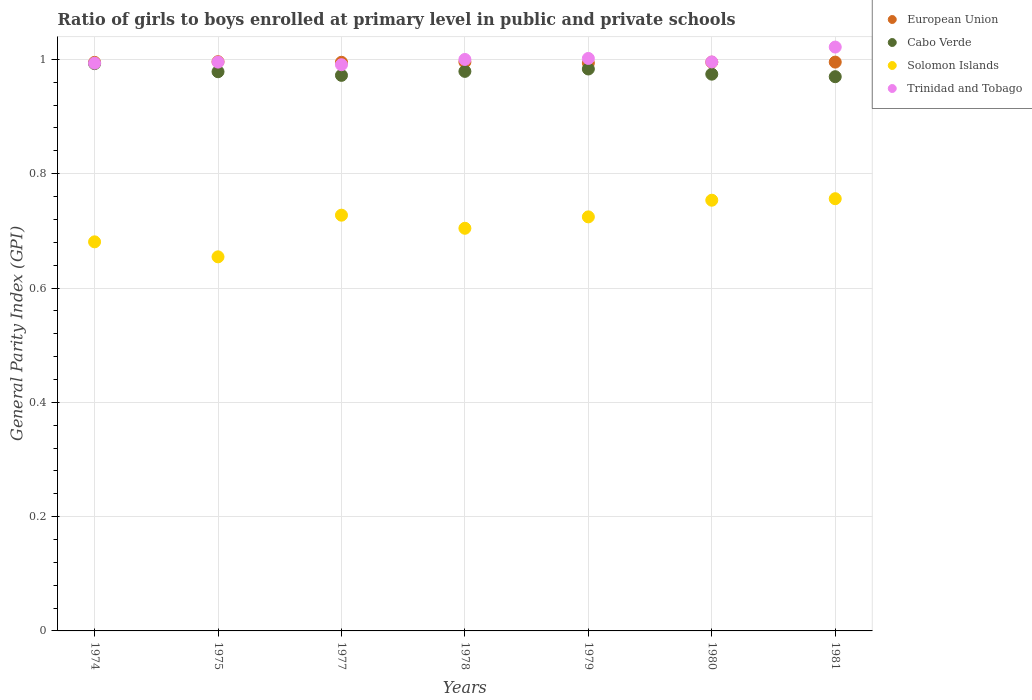What is the general parity index in Trinidad and Tobago in 1975?
Keep it short and to the point. 1. Across all years, what is the maximum general parity index in Cabo Verde?
Ensure brevity in your answer.  0.99. Across all years, what is the minimum general parity index in Trinidad and Tobago?
Your answer should be compact. 0.99. In which year was the general parity index in Solomon Islands maximum?
Provide a short and direct response. 1981. What is the total general parity index in Trinidad and Tobago in the graph?
Give a very brief answer. 7. What is the difference between the general parity index in Cabo Verde in 1978 and that in 1979?
Your response must be concise. -0. What is the difference between the general parity index in European Union in 1975 and the general parity index in Trinidad and Tobago in 1974?
Your response must be concise. 0. What is the average general parity index in Cabo Verde per year?
Offer a very short reply. 0.98. In the year 1978, what is the difference between the general parity index in Cabo Verde and general parity index in European Union?
Offer a terse response. -0.02. What is the ratio of the general parity index in European Union in 1974 to that in 1981?
Ensure brevity in your answer.  1. Is the general parity index in European Union in 1975 less than that in 1981?
Your answer should be compact. No. What is the difference between the highest and the second highest general parity index in Trinidad and Tobago?
Provide a succinct answer. 0.02. What is the difference between the highest and the lowest general parity index in Trinidad and Tobago?
Your answer should be compact. 0.03. In how many years, is the general parity index in Cabo Verde greater than the average general parity index in Cabo Verde taken over all years?
Ensure brevity in your answer.  3. Is the sum of the general parity index in Trinidad and Tobago in 1975 and 1981 greater than the maximum general parity index in Cabo Verde across all years?
Give a very brief answer. Yes. Is it the case that in every year, the sum of the general parity index in Trinidad and Tobago and general parity index in Cabo Verde  is greater than the sum of general parity index in Solomon Islands and general parity index in European Union?
Your answer should be compact. No. Is the general parity index in European Union strictly greater than the general parity index in Solomon Islands over the years?
Offer a terse response. Yes. How many years are there in the graph?
Ensure brevity in your answer.  7. Are the values on the major ticks of Y-axis written in scientific E-notation?
Ensure brevity in your answer.  No. Does the graph contain any zero values?
Offer a terse response. No. Does the graph contain grids?
Make the answer very short. Yes. Where does the legend appear in the graph?
Your response must be concise. Top right. How many legend labels are there?
Your response must be concise. 4. What is the title of the graph?
Offer a terse response. Ratio of girls to boys enrolled at primary level in public and private schools. What is the label or title of the X-axis?
Your response must be concise. Years. What is the label or title of the Y-axis?
Keep it short and to the point. General Parity Index (GPI). What is the General Parity Index (GPI) in European Union in 1974?
Your answer should be compact. 0.99. What is the General Parity Index (GPI) of Cabo Verde in 1974?
Provide a short and direct response. 0.99. What is the General Parity Index (GPI) in Solomon Islands in 1974?
Provide a short and direct response. 0.68. What is the General Parity Index (GPI) in Trinidad and Tobago in 1974?
Your answer should be compact. 0.99. What is the General Parity Index (GPI) of European Union in 1975?
Offer a terse response. 1. What is the General Parity Index (GPI) in Cabo Verde in 1975?
Offer a very short reply. 0.98. What is the General Parity Index (GPI) in Solomon Islands in 1975?
Your response must be concise. 0.65. What is the General Parity Index (GPI) in European Union in 1977?
Offer a very short reply. 0.99. What is the General Parity Index (GPI) of Cabo Verde in 1977?
Offer a terse response. 0.97. What is the General Parity Index (GPI) in Solomon Islands in 1977?
Provide a succinct answer. 0.73. What is the General Parity Index (GPI) of Trinidad and Tobago in 1977?
Ensure brevity in your answer.  0.99. What is the General Parity Index (GPI) in European Union in 1978?
Offer a terse response. 1. What is the General Parity Index (GPI) of Cabo Verde in 1978?
Your answer should be very brief. 0.98. What is the General Parity Index (GPI) in Solomon Islands in 1978?
Provide a short and direct response. 0.7. What is the General Parity Index (GPI) in Trinidad and Tobago in 1978?
Provide a succinct answer. 1. What is the General Parity Index (GPI) in European Union in 1979?
Keep it short and to the point. 0.99. What is the General Parity Index (GPI) in Cabo Verde in 1979?
Your answer should be very brief. 0.98. What is the General Parity Index (GPI) in Solomon Islands in 1979?
Your answer should be compact. 0.72. What is the General Parity Index (GPI) in Trinidad and Tobago in 1979?
Keep it short and to the point. 1. What is the General Parity Index (GPI) of European Union in 1980?
Provide a succinct answer. 1. What is the General Parity Index (GPI) of Cabo Verde in 1980?
Make the answer very short. 0.97. What is the General Parity Index (GPI) of Solomon Islands in 1980?
Your answer should be compact. 0.75. What is the General Parity Index (GPI) of Trinidad and Tobago in 1980?
Offer a terse response. 1. What is the General Parity Index (GPI) of European Union in 1981?
Provide a succinct answer. 1. What is the General Parity Index (GPI) in Cabo Verde in 1981?
Provide a short and direct response. 0.97. What is the General Parity Index (GPI) of Solomon Islands in 1981?
Give a very brief answer. 0.76. What is the General Parity Index (GPI) in Trinidad and Tobago in 1981?
Provide a succinct answer. 1.02. Across all years, what is the maximum General Parity Index (GPI) in European Union?
Offer a very short reply. 1. Across all years, what is the maximum General Parity Index (GPI) of Cabo Verde?
Provide a succinct answer. 0.99. Across all years, what is the maximum General Parity Index (GPI) in Solomon Islands?
Offer a terse response. 0.76. Across all years, what is the maximum General Parity Index (GPI) in Trinidad and Tobago?
Give a very brief answer. 1.02. Across all years, what is the minimum General Parity Index (GPI) in European Union?
Your answer should be compact. 0.99. Across all years, what is the minimum General Parity Index (GPI) of Cabo Verde?
Your response must be concise. 0.97. Across all years, what is the minimum General Parity Index (GPI) in Solomon Islands?
Provide a short and direct response. 0.65. Across all years, what is the minimum General Parity Index (GPI) in Trinidad and Tobago?
Offer a terse response. 0.99. What is the total General Parity Index (GPI) in European Union in the graph?
Offer a terse response. 6.97. What is the total General Parity Index (GPI) of Cabo Verde in the graph?
Your answer should be compact. 6.85. What is the total General Parity Index (GPI) in Solomon Islands in the graph?
Your answer should be very brief. 5. What is the total General Parity Index (GPI) in Trinidad and Tobago in the graph?
Give a very brief answer. 7. What is the difference between the General Parity Index (GPI) of European Union in 1974 and that in 1975?
Your answer should be compact. -0. What is the difference between the General Parity Index (GPI) in Cabo Verde in 1974 and that in 1975?
Provide a short and direct response. 0.01. What is the difference between the General Parity Index (GPI) in Solomon Islands in 1974 and that in 1975?
Ensure brevity in your answer.  0.03. What is the difference between the General Parity Index (GPI) of Trinidad and Tobago in 1974 and that in 1975?
Give a very brief answer. -0. What is the difference between the General Parity Index (GPI) of European Union in 1974 and that in 1977?
Provide a succinct answer. -0. What is the difference between the General Parity Index (GPI) in Cabo Verde in 1974 and that in 1977?
Offer a very short reply. 0.02. What is the difference between the General Parity Index (GPI) of Solomon Islands in 1974 and that in 1977?
Offer a terse response. -0.05. What is the difference between the General Parity Index (GPI) in Trinidad and Tobago in 1974 and that in 1977?
Give a very brief answer. 0. What is the difference between the General Parity Index (GPI) of European Union in 1974 and that in 1978?
Provide a short and direct response. -0. What is the difference between the General Parity Index (GPI) of Cabo Verde in 1974 and that in 1978?
Your answer should be very brief. 0.01. What is the difference between the General Parity Index (GPI) of Solomon Islands in 1974 and that in 1978?
Your answer should be compact. -0.02. What is the difference between the General Parity Index (GPI) of Trinidad and Tobago in 1974 and that in 1978?
Provide a short and direct response. -0.01. What is the difference between the General Parity Index (GPI) in European Union in 1974 and that in 1979?
Offer a very short reply. 0. What is the difference between the General Parity Index (GPI) in Cabo Verde in 1974 and that in 1979?
Provide a succinct answer. 0.01. What is the difference between the General Parity Index (GPI) in Solomon Islands in 1974 and that in 1979?
Offer a terse response. -0.04. What is the difference between the General Parity Index (GPI) in Trinidad and Tobago in 1974 and that in 1979?
Give a very brief answer. -0.01. What is the difference between the General Parity Index (GPI) of European Union in 1974 and that in 1980?
Offer a terse response. -0. What is the difference between the General Parity Index (GPI) of Cabo Verde in 1974 and that in 1980?
Offer a very short reply. 0.02. What is the difference between the General Parity Index (GPI) of Solomon Islands in 1974 and that in 1980?
Give a very brief answer. -0.07. What is the difference between the General Parity Index (GPI) of Trinidad and Tobago in 1974 and that in 1980?
Provide a short and direct response. -0. What is the difference between the General Parity Index (GPI) in European Union in 1974 and that in 1981?
Provide a succinct answer. -0. What is the difference between the General Parity Index (GPI) in Cabo Verde in 1974 and that in 1981?
Give a very brief answer. 0.02. What is the difference between the General Parity Index (GPI) of Solomon Islands in 1974 and that in 1981?
Provide a short and direct response. -0.08. What is the difference between the General Parity Index (GPI) of Trinidad and Tobago in 1974 and that in 1981?
Ensure brevity in your answer.  -0.03. What is the difference between the General Parity Index (GPI) of Cabo Verde in 1975 and that in 1977?
Give a very brief answer. 0.01. What is the difference between the General Parity Index (GPI) of Solomon Islands in 1975 and that in 1977?
Provide a short and direct response. -0.07. What is the difference between the General Parity Index (GPI) of Trinidad and Tobago in 1975 and that in 1977?
Make the answer very short. 0. What is the difference between the General Parity Index (GPI) in European Union in 1975 and that in 1978?
Ensure brevity in your answer.  0. What is the difference between the General Parity Index (GPI) in Cabo Verde in 1975 and that in 1978?
Ensure brevity in your answer.  -0. What is the difference between the General Parity Index (GPI) in Solomon Islands in 1975 and that in 1978?
Your answer should be compact. -0.05. What is the difference between the General Parity Index (GPI) of Trinidad and Tobago in 1975 and that in 1978?
Give a very brief answer. -0. What is the difference between the General Parity Index (GPI) in European Union in 1975 and that in 1979?
Your response must be concise. 0. What is the difference between the General Parity Index (GPI) of Cabo Verde in 1975 and that in 1979?
Provide a succinct answer. -0. What is the difference between the General Parity Index (GPI) in Solomon Islands in 1975 and that in 1979?
Provide a succinct answer. -0.07. What is the difference between the General Parity Index (GPI) of Trinidad and Tobago in 1975 and that in 1979?
Provide a short and direct response. -0.01. What is the difference between the General Parity Index (GPI) in European Union in 1975 and that in 1980?
Provide a succinct answer. 0. What is the difference between the General Parity Index (GPI) of Cabo Verde in 1975 and that in 1980?
Offer a very short reply. 0. What is the difference between the General Parity Index (GPI) in Solomon Islands in 1975 and that in 1980?
Your response must be concise. -0.1. What is the difference between the General Parity Index (GPI) of Trinidad and Tobago in 1975 and that in 1980?
Your answer should be compact. -0. What is the difference between the General Parity Index (GPI) in European Union in 1975 and that in 1981?
Make the answer very short. 0. What is the difference between the General Parity Index (GPI) in Cabo Verde in 1975 and that in 1981?
Offer a very short reply. 0.01. What is the difference between the General Parity Index (GPI) of Solomon Islands in 1975 and that in 1981?
Your answer should be very brief. -0.1. What is the difference between the General Parity Index (GPI) of Trinidad and Tobago in 1975 and that in 1981?
Your answer should be compact. -0.03. What is the difference between the General Parity Index (GPI) of European Union in 1977 and that in 1978?
Your response must be concise. -0. What is the difference between the General Parity Index (GPI) in Cabo Verde in 1977 and that in 1978?
Your response must be concise. -0.01. What is the difference between the General Parity Index (GPI) in Solomon Islands in 1977 and that in 1978?
Your response must be concise. 0.02. What is the difference between the General Parity Index (GPI) in Trinidad and Tobago in 1977 and that in 1978?
Make the answer very short. -0.01. What is the difference between the General Parity Index (GPI) in European Union in 1977 and that in 1979?
Make the answer very short. 0. What is the difference between the General Parity Index (GPI) of Cabo Verde in 1977 and that in 1979?
Offer a very short reply. -0.01. What is the difference between the General Parity Index (GPI) of Solomon Islands in 1977 and that in 1979?
Offer a very short reply. 0. What is the difference between the General Parity Index (GPI) in Trinidad and Tobago in 1977 and that in 1979?
Ensure brevity in your answer.  -0.01. What is the difference between the General Parity Index (GPI) of European Union in 1977 and that in 1980?
Give a very brief answer. -0. What is the difference between the General Parity Index (GPI) of Cabo Verde in 1977 and that in 1980?
Provide a succinct answer. -0. What is the difference between the General Parity Index (GPI) in Solomon Islands in 1977 and that in 1980?
Your response must be concise. -0.03. What is the difference between the General Parity Index (GPI) in Trinidad and Tobago in 1977 and that in 1980?
Provide a succinct answer. -0. What is the difference between the General Parity Index (GPI) of European Union in 1977 and that in 1981?
Your answer should be very brief. -0. What is the difference between the General Parity Index (GPI) of Cabo Verde in 1977 and that in 1981?
Provide a short and direct response. 0. What is the difference between the General Parity Index (GPI) in Solomon Islands in 1977 and that in 1981?
Make the answer very short. -0.03. What is the difference between the General Parity Index (GPI) of Trinidad and Tobago in 1977 and that in 1981?
Provide a short and direct response. -0.03. What is the difference between the General Parity Index (GPI) of European Union in 1978 and that in 1979?
Your answer should be very brief. 0. What is the difference between the General Parity Index (GPI) in Cabo Verde in 1978 and that in 1979?
Provide a succinct answer. -0. What is the difference between the General Parity Index (GPI) of Solomon Islands in 1978 and that in 1979?
Offer a terse response. -0.02. What is the difference between the General Parity Index (GPI) of Trinidad and Tobago in 1978 and that in 1979?
Ensure brevity in your answer.  -0. What is the difference between the General Parity Index (GPI) in Cabo Verde in 1978 and that in 1980?
Your answer should be very brief. 0. What is the difference between the General Parity Index (GPI) in Solomon Islands in 1978 and that in 1980?
Provide a short and direct response. -0.05. What is the difference between the General Parity Index (GPI) in Trinidad and Tobago in 1978 and that in 1980?
Your answer should be very brief. 0. What is the difference between the General Parity Index (GPI) of European Union in 1978 and that in 1981?
Offer a terse response. 0. What is the difference between the General Parity Index (GPI) in Cabo Verde in 1978 and that in 1981?
Provide a succinct answer. 0.01. What is the difference between the General Parity Index (GPI) of Solomon Islands in 1978 and that in 1981?
Keep it short and to the point. -0.05. What is the difference between the General Parity Index (GPI) in Trinidad and Tobago in 1978 and that in 1981?
Offer a very short reply. -0.02. What is the difference between the General Parity Index (GPI) of European Union in 1979 and that in 1980?
Make the answer very short. -0. What is the difference between the General Parity Index (GPI) in Cabo Verde in 1979 and that in 1980?
Your response must be concise. 0.01. What is the difference between the General Parity Index (GPI) in Solomon Islands in 1979 and that in 1980?
Your answer should be very brief. -0.03. What is the difference between the General Parity Index (GPI) in Trinidad and Tobago in 1979 and that in 1980?
Your answer should be very brief. 0.01. What is the difference between the General Parity Index (GPI) in European Union in 1979 and that in 1981?
Make the answer very short. -0. What is the difference between the General Parity Index (GPI) in Cabo Verde in 1979 and that in 1981?
Your response must be concise. 0.01. What is the difference between the General Parity Index (GPI) in Solomon Islands in 1979 and that in 1981?
Provide a short and direct response. -0.03. What is the difference between the General Parity Index (GPI) of Trinidad and Tobago in 1979 and that in 1981?
Your answer should be very brief. -0.02. What is the difference between the General Parity Index (GPI) in European Union in 1980 and that in 1981?
Provide a succinct answer. -0. What is the difference between the General Parity Index (GPI) in Cabo Verde in 1980 and that in 1981?
Your answer should be very brief. 0. What is the difference between the General Parity Index (GPI) in Solomon Islands in 1980 and that in 1981?
Make the answer very short. -0. What is the difference between the General Parity Index (GPI) in Trinidad and Tobago in 1980 and that in 1981?
Keep it short and to the point. -0.03. What is the difference between the General Parity Index (GPI) of European Union in 1974 and the General Parity Index (GPI) of Cabo Verde in 1975?
Provide a succinct answer. 0.02. What is the difference between the General Parity Index (GPI) of European Union in 1974 and the General Parity Index (GPI) of Solomon Islands in 1975?
Keep it short and to the point. 0.34. What is the difference between the General Parity Index (GPI) of European Union in 1974 and the General Parity Index (GPI) of Trinidad and Tobago in 1975?
Your answer should be compact. -0. What is the difference between the General Parity Index (GPI) in Cabo Verde in 1974 and the General Parity Index (GPI) in Solomon Islands in 1975?
Your answer should be very brief. 0.34. What is the difference between the General Parity Index (GPI) in Cabo Verde in 1974 and the General Parity Index (GPI) in Trinidad and Tobago in 1975?
Provide a succinct answer. -0. What is the difference between the General Parity Index (GPI) in Solomon Islands in 1974 and the General Parity Index (GPI) in Trinidad and Tobago in 1975?
Provide a succinct answer. -0.31. What is the difference between the General Parity Index (GPI) of European Union in 1974 and the General Parity Index (GPI) of Cabo Verde in 1977?
Your answer should be very brief. 0.02. What is the difference between the General Parity Index (GPI) of European Union in 1974 and the General Parity Index (GPI) of Solomon Islands in 1977?
Ensure brevity in your answer.  0.27. What is the difference between the General Parity Index (GPI) of European Union in 1974 and the General Parity Index (GPI) of Trinidad and Tobago in 1977?
Your answer should be very brief. 0. What is the difference between the General Parity Index (GPI) in Cabo Verde in 1974 and the General Parity Index (GPI) in Solomon Islands in 1977?
Offer a terse response. 0.27. What is the difference between the General Parity Index (GPI) in Cabo Verde in 1974 and the General Parity Index (GPI) in Trinidad and Tobago in 1977?
Ensure brevity in your answer.  0. What is the difference between the General Parity Index (GPI) of Solomon Islands in 1974 and the General Parity Index (GPI) of Trinidad and Tobago in 1977?
Make the answer very short. -0.31. What is the difference between the General Parity Index (GPI) in European Union in 1974 and the General Parity Index (GPI) in Cabo Verde in 1978?
Provide a short and direct response. 0.02. What is the difference between the General Parity Index (GPI) in European Union in 1974 and the General Parity Index (GPI) in Solomon Islands in 1978?
Your answer should be compact. 0.29. What is the difference between the General Parity Index (GPI) of European Union in 1974 and the General Parity Index (GPI) of Trinidad and Tobago in 1978?
Offer a terse response. -0.01. What is the difference between the General Parity Index (GPI) of Cabo Verde in 1974 and the General Parity Index (GPI) of Solomon Islands in 1978?
Your response must be concise. 0.29. What is the difference between the General Parity Index (GPI) in Cabo Verde in 1974 and the General Parity Index (GPI) in Trinidad and Tobago in 1978?
Provide a succinct answer. -0.01. What is the difference between the General Parity Index (GPI) in Solomon Islands in 1974 and the General Parity Index (GPI) in Trinidad and Tobago in 1978?
Your answer should be very brief. -0.32. What is the difference between the General Parity Index (GPI) of European Union in 1974 and the General Parity Index (GPI) of Cabo Verde in 1979?
Keep it short and to the point. 0.01. What is the difference between the General Parity Index (GPI) in European Union in 1974 and the General Parity Index (GPI) in Solomon Islands in 1979?
Your answer should be very brief. 0.27. What is the difference between the General Parity Index (GPI) of European Union in 1974 and the General Parity Index (GPI) of Trinidad and Tobago in 1979?
Provide a short and direct response. -0.01. What is the difference between the General Parity Index (GPI) in Cabo Verde in 1974 and the General Parity Index (GPI) in Solomon Islands in 1979?
Your answer should be compact. 0.27. What is the difference between the General Parity Index (GPI) of Cabo Verde in 1974 and the General Parity Index (GPI) of Trinidad and Tobago in 1979?
Keep it short and to the point. -0.01. What is the difference between the General Parity Index (GPI) in Solomon Islands in 1974 and the General Parity Index (GPI) in Trinidad and Tobago in 1979?
Offer a terse response. -0.32. What is the difference between the General Parity Index (GPI) of European Union in 1974 and the General Parity Index (GPI) of Cabo Verde in 1980?
Provide a succinct answer. 0.02. What is the difference between the General Parity Index (GPI) of European Union in 1974 and the General Parity Index (GPI) of Solomon Islands in 1980?
Your answer should be very brief. 0.24. What is the difference between the General Parity Index (GPI) of European Union in 1974 and the General Parity Index (GPI) of Trinidad and Tobago in 1980?
Ensure brevity in your answer.  -0. What is the difference between the General Parity Index (GPI) in Cabo Verde in 1974 and the General Parity Index (GPI) in Solomon Islands in 1980?
Provide a succinct answer. 0.24. What is the difference between the General Parity Index (GPI) in Cabo Verde in 1974 and the General Parity Index (GPI) in Trinidad and Tobago in 1980?
Your answer should be very brief. -0. What is the difference between the General Parity Index (GPI) of Solomon Islands in 1974 and the General Parity Index (GPI) of Trinidad and Tobago in 1980?
Ensure brevity in your answer.  -0.31. What is the difference between the General Parity Index (GPI) of European Union in 1974 and the General Parity Index (GPI) of Cabo Verde in 1981?
Make the answer very short. 0.03. What is the difference between the General Parity Index (GPI) in European Union in 1974 and the General Parity Index (GPI) in Solomon Islands in 1981?
Keep it short and to the point. 0.24. What is the difference between the General Parity Index (GPI) of European Union in 1974 and the General Parity Index (GPI) of Trinidad and Tobago in 1981?
Provide a short and direct response. -0.03. What is the difference between the General Parity Index (GPI) in Cabo Verde in 1974 and the General Parity Index (GPI) in Solomon Islands in 1981?
Offer a terse response. 0.24. What is the difference between the General Parity Index (GPI) of Cabo Verde in 1974 and the General Parity Index (GPI) of Trinidad and Tobago in 1981?
Provide a short and direct response. -0.03. What is the difference between the General Parity Index (GPI) in Solomon Islands in 1974 and the General Parity Index (GPI) in Trinidad and Tobago in 1981?
Make the answer very short. -0.34. What is the difference between the General Parity Index (GPI) in European Union in 1975 and the General Parity Index (GPI) in Cabo Verde in 1977?
Make the answer very short. 0.02. What is the difference between the General Parity Index (GPI) in European Union in 1975 and the General Parity Index (GPI) in Solomon Islands in 1977?
Your response must be concise. 0.27. What is the difference between the General Parity Index (GPI) of European Union in 1975 and the General Parity Index (GPI) of Trinidad and Tobago in 1977?
Ensure brevity in your answer.  0.01. What is the difference between the General Parity Index (GPI) in Cabo Verde in 1975 and the General Parity Index (GPI) in Solomon Islands in 1977?
Offer a very short reply. 0.25. What is the difference between the General Parity Index (GPI) in Cabo Verde in 1975 and the General Parity Index (GPI) in Trinidad and Tobago in 1977?
Your answer should be very brief. -0.01. What is the difference between the General Parity Index (GPI) in Solomon Islands in 1975 and the General Parity Index (GPI) in Trinidad and Tobago in 1977?
Your answer should be very brief. -0.34. What is the difference between the General Parity Index (GPI) in European Union in 1975 and the General Parity Index (GPI) in Cabo Verde in 1978?
Your response must be concise. 0.02. What is the difference between the General Parity Index (GPI) of European Union in 1975 and the General Parity Index (GPI) of Solomon Islands in 1978?
Your response must be concise. 0.29. What is the difference between the General Parity Index (GPI) in European Union in 1975 and the General Parity Index (GPI) in Trinidad and Tobago in 1978?
Your response must be concise. -0. What is the difference between the General Parity Index (GPI) in Cabo Verde in 1975 and the General Parity Index (GPI) in Solomon Islands in 1978?
Ensure brevity in your answer.  0.27. What is the difference between the General Parity Index (GPI) in Cabo Verde in 1975 and the General Parity Index (GPI) in Trinidad and Tobago in 1978?
Your response must be concise. -0.02. What is the difference between the General Parity Index (GPI) in Solomon Islands in 1975 and the General Parity Index (GPI) in Trinidad and Tobago in 1978?
Provide a short and direct response. -0.35. What is the difference between the General Parity Index (GPI) of European Union in 1975 and the General Parity Index (GPI) of Cabo Verde in 1979?
Make the answer very short. 0.01. What is the difference between the General Parity Index (GPI) of European Union in 1975 and the General Parity Index (GPI) of Solomon Islands in 1979?
Ensure brevity in your answer.  0.27. What is the difference between the General Parity Index (GPI) in European Union in 1975 and the General Parity Index (GPI) in Trinidad and Tobago in 1979?
Ensure brevity in your answer.  -0.01. What is the difference between the General Parity Index (GPI) in Cabo Verde in 1975 and the General Parity Index (GPI) in Solomon Islands in 1979?
Offer a terse response. 0.25. What is the difference between the General Parity Index (GPI) in Cabo Verde in 1975 and the General Parity Index (GPI) in Trinidad and Tobago in 1979?
Ensure brevity in your answer.  -0.02. What is the difference between the General Parity Index (GPI) of Solomon Islands in 1975 and the General Parity Index (GPI) of Trinidad and Tobago in 1979?
Offer a very short reply. -0.35. What is the difference between the General Parity Index (GPI) of European Union in 1975 and the General Parity Index (GPI) of Cabo Verde in 1980?
Offer a very short reply. 0.02. What is the difference between the General Parity Index (GPI) of European Union in 1975 and the General Parity Index (GPI) of Solomon Islands in 1980?
Ensure brevity in your answer.  0.24. What is the difference between the General Parity Index (GPI) in European Union in 1975 and the General Parity Index (GPI) in Trinidad and Tobago in 1980?
Ensure brevity in your answer.  0. What is the difference between the General Parity Index (GPI) in Cabo Verde in 1975 and the General Parity Index (GPI) in Solomon Islands in 1980?
Your response must be concise. 0.22. What is the difference between the General Parity Index (GPI) in Cabo Verde in 1975 and the General Parity Index (GPI) in Trinidad and Tobago in 1980?
Offer a terse response. -0.02. What is the difference between the General Parity Index (GPI) of Solomon Islands in 1975 and the General Parity Index (GPI) of Trinidad and Tobago in 1980?
Offer a terse response. -0.34. What is the difference between the General Parity Index (GPI) of European Union in 1975 and the General Parity Index (GPI) of Cabo Verde in 1981?
Make the answer very short. 0.03. What is the difference between the General Parity Index (GPI) of European Union in 1975 and the General Parity Index (GPI) of Solomon Islands in 1981?
Offer a very short reply. 0.24. What is the difference between the General Parity Index (GPI) in European Union in 1975 and the General Parity Index (GPI) in Trinidad and Tobago in 1981?
Make the answer very short. -0.03. What is the difference between the General Parity Index (GPI) in Cabo Verde in 1975 and the General Parity Index (GPI) in Solomon Islands in 1981?
Your answer should be very brief. 0.22. What is the difference between the General Parity Index (GPI) of Cabo Verde in 1975 and the General Parity Index (GPI) of Trinidad and Tobago in 1981?
Ensure brevity in your answer.  -0.04. What is the difference between the General Parity Index (GPI) of Solomon Islands in 1975 and the General Parity Index (GPI) of Trinidad and Tobago in 1981?
Make the answer very short. -0.37. What is the difference between the General Parity Index (GPI) in European Union in 1977 and the General Parity Index (GPI) in Cabo Verde in 1978?
Your answer should be very brief. 0.02. What is the difference between the General Parity Index (GPI) of European Union in 1977 and the General Parity Index (GPI) of Solomon Islands in 1978?
Make the answer very short. 0.29. What is the difference between the General Parity Index (GPI) of European Union in 1977 and the General Parity Index (GPI) of Trinidad and Tobago in 1978?
Offer a very short reply. -0. What is the difference between the General Parity Index (GPI) of Cabo Verde in 1977 and the General Parity Index (GPI) of Solomon Islands in 1978?
Offer a very short reply. 0.27. What is the difference between the General Parity Index (GPI) in Cabo Verde in 1977 and the General Parity Index (GPI) in Trinidad and Tobago in 1978?
Make the answer very short. -0.03. What is the difference between the General Parity Index (GPI) in Solomon Islands in 1977 and the General Parity Index (GPI) in Trinidad and Tobago in 1978?
Give a very brief answer. -0.27. What is the difference between the General Parity Index (GPI) in European Union in 1977 and the General Parity Index (GPI) in Cabo Verde in 1979?
Provide a short and direct response. 0.01. What is the difference between the General Parity Index (GPI) in European Union in 1977 and the General Parity Index (GPI) in Solomon Islands in 1979?
Provide a short and direct response. 0.27. What is the difference between the General Parity Index (GPI) in European Union in 1977 and the General Parity Index (GPI) in Trinidad and Tobago in 1979?
Your response must be concise. -0.01. What is the difference between the General Parity Index (GPI) in Cabo Verde in 1977 and the General Parity Index (GPI) in Solomon Islands in 1979?
Give a very brief answer. 0.25. What is the difference between the General Parity Index (GPI) in Cabo Verde in 1977 and the General Parity Index (GPI) in Trinidad and Tobago in 1979?
Give a very brief answer. -0.03. What is the difference between the General Parity Index (GPI) in Solomon Islands in 1977 and the General Parity Index (GPI) in Trinidad and Tobago in 1979?
Ensure brevity in your answer.  -0.27. What is the difference between the General Parity Index (GPI) of European Union in 1977 and the General Parity Index (GPI) of Cabo Verde in 1980?
Your answer should be compact. 0.02. What is the difference between the General Parity Index (GPI) of European Union in 1977 and the General Parity Index (GPI) of Solomon Islands in 1980?
Your response must be concise. 0.24. What is the difference between the General Parity Index (GPI) of European Union in 1977 and the General Parity Index (GPI) of Trinidad and Tobago in 1980?
Offer a terse response. -0. What is the difference between the General Parity Index (GPI) in Cabo Verde in 1977 and the General Parity Index (GPI) in Solomon Islands in 1980?
Give a very brief answer. 0.22. What is the difference between the General Parity Index (GPI) in Cabo Verde in 1977 and the General Parity Index (GPI) in Trinidad and Tobago in 1980?
Make the answer very short. -0.02. What is the difference between the General Parity Index (GPI) in Solomon Islands in 1977 and the General Parity Index (GPI) in Trinidad and Tobago in 1980?
Your answer should be very brief. -0.27. What is the difference between the General Parity Index (GPI) in European Union in 1977 and the General Parity Index (GPI) in Cabo Verde in 1981?
Your answer should be very brief. 0.03. What is the difference between the General Parity Index (GPI) in European Union in 1977 and the General Parity Index (GPI) in Solomon Islands in 1981?
Make the answer very short. 0.24. What is the difference between the General Parity Index (GPI) in European Union in 1977 and the General Parity Index (GPI) in Trinidad and Tobago in 1981?
Your response must be concise. -0.03. What is the difference between the General Parity Index (GPI) of Cabo Verde in 1977 and the General Parity Index (GPI) of Solomon Islands in 1981?
Provide a short and direct response. 0.22. What is the difference between the General Parity Index (GPI) of Cabo Verde in 1977 and the General Parity Index (GPI) of Trinidad and Tobago in 1981?
Offer a terse response. -0.05. What is the difference between the General Parity Index (GPI) in Solomon Islands in 1977 and the General Parity Index (GPI) in Trinidad and Tobago in 1981?
Your answer should be compact. -0.29. What is the difference between the General Parity Index (GPI) of European Union in 1978 and the General Parity Index (GPI) of Cabo Verde in 1979?
Offer a very short reply. 0.01. What is the difference between the General Parity Index (GPI) of European Union in 1978 and the General Parity Index (GPI) of Solomon Islands in 1979?
Provide a succinct answer. 0.27. What is the difference between the General Parity Index (GPI) in European Union in 1978 and the General Parity Index (GPI) in Trinidad and Tobago in 1979?
Keep it short and to the point. -0.01. What is the difference between the General Parity Index (GPI) of Cabo Verde in 1978 and the General Parity Index (GPI) of Solomon Islands in 1979?
Provide a succinct answer. 0.25. What is the difference between the General Parity Index (GPI) of Cabo Verde in 1978 and the General Parity Index (GPI) of Trinidad and Tobago in 1979?
Give a very brief answer. -0.02. What is the difference between the General Parity Index (GPI) in Solomon Islands in 1978 and the General Parity Index (GPI) in Trinidad and Tobago in 1979?
Offer a very short reply. -0.3. What is the difference between the General Parity Index (GPI) of European Union in 1978 and the General Parity Index (GPI) of Cabo Verde in 1980?
Provide a short and direct response. 0.02. What is the difference between the General Parity Index (GPI) in European Union in 1978 and the General Parity Index (GPI) in Solomon Islands in 1980?
Keep it short and to the point. 0.24. What is the difference between the General Parity Index (GPI) in European Union in 1978 and the General Parity Index (GPI) in Trinidad and Tobago in 1980?
Make the answer very short. -0. What is the difference between the General Parity Index (GPI) of Cabo Verde in 1978 and the General Parity Index (GPI) of Solomon Islands in 1980?
Ensure brevity in your answer.  0.23. What is the difference between the General Parity Index (GPI) in Cabo Verde in 1978 and the General Parity Index (GPI) in Trinidad and Tobago in 1980?
Ensure brevity in your answer.  -0.02. What is the difference between the General Parity Index (GPI) of Solomon Islands in 1978 and the General Parity Index (GPI) of Trinidad and Tobago in 1980?
Your answer should be very brief. -0.29. What is the difference between the General Parity Index (GPI) of European Union in 1978 and the General Parity Index (GPI) of Cabo Verde in 1981?
Offer a very short reply. 0.03. What is the difference between the General Parity Index (GPI) of European Union in 1978 and the General Parity Index (GPI) of Solomon Islands in 1981?
Make the answer very short. 0.24. What is the difference between the General Parity Index (GPI) in European Union in 1978 and the General Parity Index (GPI) in Trinidad and Tobago in 1981?
Keep it short and to the point. -0.03. What is the difference between the General Parity Index (GPI) in Cabo Verde in 1978 and the General Parity Index (GPI) in Solomon Islands in 1981?
Your response must be concise. 0.22. What is the difference between the General Parity Index (GPI) of Cabo Verde in 1978 and the General Parity Index (GPI) of Trinidad and Tobago in 1981?
Your response must be concise. -0.04. What is the difference between the General Parity Index (GPI) of Solomon Islands in 1978 and the General Parity Index (GPI) of Trinidad and Tobago in 1981?
Your answer should be very brief. -0.32. What is the difference between the General Parity Index (GPI) of European Union in 1979 and the General Parity Index (GPI) of Cabo Verde in 1980?
Your answer should be very brief. 0.02. What is the difference between the General Parity Index (GPI) in European Union in 1979 and the General Parity Index (GPI) in Solomon Islands in 1980?
Your response must be concise. 0.24. What is the difference between the General Parity Index (GPI) in European Union in 1979 and the General Parity Index (GPI) in Trinidad and Tobago in 1980?
Offer a terse response. -0. What is the difference between the General Parity Index (GPI) of Cabo Verde in 1979 and the General Parity Index (GPI) of Solomon Islands in 1980?
Offer a terse response. 0.23. What is the difference between the General Parity Index (GPI) of Cabo Verde in 1979 and the General Parity Index (GPI) of Trinidad and Tobago in 1980?
Offer a very short reply. -0.01. What is the difference between the General Parity Index (GPI) in Solomon Islands in 1979 and the General Parity Index (GPI) in Trinidad and Tobago in 1980?
Give a very brief answer. -0.27. What is the difference between the General Parity Index (GPI) of European Union in 1979 and the General Parity Index (GPI) of Cabo Verde in 1981?
Your answer should be compact. 0.02. What is the difference between the General Parity Index (GPI) in European Union in 1979 and the General Parity Index (GPI) in Solomon Islands in 1981?
Offer a terse response. 0.24. What is the difference between the General Parity Index (GPI) in European Union in 1979 and the General Parity Index (GPI) in Trinidad and Tobago in 1981?
Your answer should be very brief. -0.03. What is the difference between the General Parity Index (GPI) in Cabo Verde in 1979 and the General Parity Index (GPI) in Solomon Islands in 1981?
Provide a short and direct response. 0.23. What is the difference between the General Parity Index (GPI) in Cabo Verde in 1979 and the General Parity Index (GPI) in Trinidad and Tobago in 1981?
Offer a very short reply. -0.04. What is the difference between the General Parity Index (GPI) of Solomon Islands in 1979 and the General Parity Index (GPI) of Trinidad and Tobago in 1981?
Provide a succinct answer. -0.3. What is the difference between the General Parity Index (GPI) in European Union in 1980 and the General Parity Index (GPI) in Cabo Verde in 1981?
Keep it short and to the point. 0.03. What is the difference between the General Parity Index (GPI) of European Union in 1980 and the General Parity Index (GPI) of Solomon Islands in 1981?
Make the answer very short. 0.24. What is the difference between the General Parity Index (GPI) of European Union in 1980 and the General Parity Index (GPI) of Trinidad and Tobago in 1981?
Keep it short and to the point. -0.03. What is the difference between the General Parity Index (GPI) of Cabo Verde in 1980 and the General Parity Index (GPI) of Solomon Islands in 1981?
Offer a very short reply. 0.22. What is the difference between the General Parity Index (GPI) in Cabo Verde in 1980 and the General Parity Index (GPI) in Trinidad and Tobago in 1981?
Make the answer very short. -0.05. What is the difference between the General Parity Index (GPI) of Solomon Islands in 1980 and the General Parity Index (GPI) of Trinidad and Tobago in 1981?
Your response must be concise. -0.27. What is the average General Parity Index (GPI) in Cabo Verde per year?
Offer a very short reply. 0.98. What is the average General Parity Index (GPI) of Solomon Islands per year?
Ensure brevity in your answer.  0.71. In the year 1974, what is the difference between the General Parity Index (GPI) in European Union and General Parity Index (GPI) in Cabo Verde?
Give a very brief answer. 0. In the year 1974, what is the difference between the General Parity Index (GPI) in European Union and General Parity Index (GPI) in Solomon Islands?
Make the answer very short. 0.31. In the year 1974, what is the difference between the General Parity Index (GPI) of European Union and General Parity Index (GPI) of Trinidad and Tobago?
Ensure brevity in your answer.  0. In the year 1974, what is the difference between the General Parity Index (GPI) in Cabo Verde and General Parity Index (GPI) in Solomon Islands?
Give a very brief answer. 0.31. In the year 1974, what is the difference between the General Parity Index (GPI) of Cabo Verde and General Parity Index (GPI) of Trinidad and Tobago?
Offer a terse response. -0. In the year 1974, what is the difference between the General Parity Index (GPI) in Solomon Islands and General Parity Index (GPI) in Trinidad and Tobago?
Your response must be concise. -0.31. In the year 1975, what is the difference between the General Parity Index (GPI) of European Union and General Parity Index (GPI) of Cabo Verde?
Provide a succinct answer. 0.02. In the year 1975, what is the difference between the General Parity Index (GPI) of European Union and General Parity Index (GPI) of Solomon Islands?
Give a very brief answer. 0.34. In the year 1975, what is the difference between the General Parity Index (GPI) in European Union and General Parity Index (GPI) in Trinidad and Tobago?
Your answer should be very brief. 0. In the year 1975, what is the difference between the General Parity Index (GPI) of Cabo Verde and General Parity Index (GPI) of Solomon Islands?
Your response must be concise. 0.32. In the year 1975, what is the difference between the General Parity Index (GPI) in Cabo Verde and General Parity Index (GPI) in Trinidad and Tobago?
Ensure brevity in your answer.  -0.02. In the year 1975, what is the difference between the General Parity Index (GPI) of Solomon Islands and General Parity Index (GPI) of Trinidad and Tobago?
Keep it short and to the point. -0.34. In the year 1977, what is the difference between the General Parity Index (GPI) in European Union and General Parity Index (GPI) in Cabo Verde?
Keep it short and to the point. 0.02. In the year 1977, what is the difference between the General Parity Index (GPI) in European Union and General Parity Index (GPI) in Solomon Islands?
Keep it short and to the point. 0.27. In the year 1977, what is the difference between the General Parity Index (GPI) in European Union and General Parity Index (GPI) in Trinidad and Tobago?
Ensure brevity in your answer.  0. In the year 1977, what is the difference between the General Parity Index (GPI) in Cabo Verde and General Parity Index (GPI) in Solomon Islands?
Ensure brevity in your answer.  0.24. In the year 1977, what is the difference between the General Parity Index (GPI) of Cabo Verde and General Parity Index (GPI) of Trinidad and Tobago?
Your answer should be very brief. -0.02. In the year 1977, what is the difference between the General Parity Index (GPI) of Solomon Islands and General Parity Index (GPI) of Trinidad and Tobago?
Offer a terse response. -0.26. In the year 1978, what is the difference between the General Parity Index (GPI) in European Union and General Parity Index (GPI) in Cabo Verde?
Keep it short and to the point. 0.02. In the year 1978, what is the difference between the General Parity Index (GPI) of European Union and General Parity Index (GPI) of Solomon Islands?
Make the answer very short. 0.29. In the year 1978, what is the difference between the General Parity Index (GPI) in European Union and General Parity Index (GPI) in Trinidad and Tobago?
Make the answer very short. -0. In the year 1978, what is the difference between the General Parity Index (GPI) of Cabo Verde and General Parity Index (GPI) of Solomon Islands?
Keep it short and to the point. 0.27. In the year 1978, what is the difference between the General Parity Index (GPI) of Cabo Verde and General Parity Index (GPI) of Trinidad and Tobago?
Your response must be concise. -0.02. In the year 1978, what is the difference between the General Parity Index (GPI) of Solomon Islands and General Parity Index (GPI) of Trinidad and Tobago?
Give a very brief answer. -0.3. In the year 1979, what is the difference between the General Parity Index (GPI) of European Union and General Parity Index (GPI) of Cabo Verde?
Provide a short and direct response. 0.01. In the year 1979, what is the difference between the General Parity Index (GPI) in European Union and General Parity Index (GPI) in Solomon Islands?
Offer a very short reply. 0.27. In the year 1979, what is the difference between the General Parity Index (GPI) in European Union and General Parity Index (GPI) in Trinidad and Tobago?
Your response must be concise. -0.01. In the year 1979, what is the difference between the General Parity Index (GPI) of Cabo Verde and General Parity Index (GPI) of Solomon Islands?
Keep it short and to the point. 0.26. In the year 1979, what is the difference between the General Parity Index (GPI) of Cabo Verde and General Parity Index (GPI) of Trinidad and Tobago?
Provide a succinct answer. -0.02. In the year 1979, what is the difference between the General Parity Index (GPI) of Solomon Islands and General Parity Index (GPI) of Trinidad and Tobago?
Your response must be concise. -0.28. In the year 1980, what is the difference between the General Parity Index (GPI) in European Union and General Parity Index (GPI) in Cabo Verde?
Your answer should be very brief. 0.02. In the year 1980, what is the difference between the General Parity Index (GPI) of European Union and General Parity Index (GPI) of Solomon Islands?
Ensure brevity in your answer.  0.24. In the year 1980, what is the difference between the General Parity Index (GPI) in European Union and General Parity Index (GPI) in Trinidad and Tobago?
Provide a short and direct response. -0. In the year 1980, what is the difference between the General Parity Index (GPI) of Cabo Verde and General Parity Index (GPI) of Solomon Islands?
Keep it short and to the point. 0.22. In the year 1980, what is the difference between the General Parity Index (GPI) in Cabo Verde and General Parity Index (GPI) in Trinidad and Tobago?
Ensure brevity in your answer.  -0.02. In the year 1980, what is the difference between the General Parity Index (GPI) of Solomon Islands and General Parity Index (GPI) of Trinidad and Tobago?
Keep it short and to the point. -0.24. In the year 1981, what is the difference between the General Parity Index (GPI) in European Union and General Parity Index (GPI) in Cabo Verde?
Make the answer very short. 0.03. In the year 1981, what is the difference between the General Parity Index (GPI) in European Union and General Parity Index (GPI) in Solomon Islands?
Ensure brevity in your answer.  0.24. In the year 1981, what is the difference between the General Parity Index (GPI) of European Union and General Parity Index (GPI) of Trinidad and Tobago?
Keep it short and to the point. -0.03. In the year 1981, what is the difference between the General Parity Index (GPI) in Cabo Verde and General Parity Index (GPI) in Solomon Islands?
Provide a short and direct response. 0.21. In the year 1981, what is the difference between the General Parity Index (GPI) in Cabo Verde and General Parity Index (GPI) in Trinidad and Tobago?
Ensure brevity in your answer.  -0.05. In the year 1981, what is the difference between the General Parity Index (GPI) of Solomon Islands and General Parity Index (GPI) of Trinidad and Tobago?
Your answer should be very brief. -0.27. What is the ratio of the General Parity Index (GPI) of European Union in 1974 to that in 1975?
Give a very brief answer. 1. What is the ratio of the General Parity Index (GPI) in Cabo Verde in 1974 to that in 1975?
Your answer should be compact. 1.01. What is the ratio of the General Parity Index (GPI) in Solomon Islands in 1974 to that in 1975?
Offer a very short reply. 1.04. What is the ratio of the General Parity Index (GPI) in European Union in 1974 to that in 1977?
Your answer should be compact. 1. What is the ratio of the General Parity Index (GPI) in Cabo Verde in 1974 to that in 1977?
Ensure brevity in your answer.  1.02. What is the ratio of the General Parity Index (GPI) in Solomon Islands in 1974 to that in 1977?
Your answer should be compact. 0.94. What is the ratio of the General Parity Index (GPI) of Trinidad and Tobago in 1974 to that in 1977?
Provide a succinct answer. 1. What is the ratio of the General Parity Index (GPI) in Cabo Verde in 1974 to that in 1978?
Your response must be concise. 1.01. What is the ratio of the General Parity Index (GPI) of Solomon Islands in 1974 to that in 1978?
Keep it short and to the point. 0.97. What is the ratio of the General Parity Index (GPI) in Trinidad and Tobago in 1974 to that in 1978?
Keep it short and to the point. 0.99. What is the ratio of the General Parity Index (GPI) of European Union in 1974 to that in 1979?
Offer a terse response. 1. What is the ratio of the General Parity Index (GPI) of Cabo Verde in 1974 to that in 1979?
Provide a short and direct response. 1.01. What is the ratio of the General Parity Index (GPI) of Solomon Islands in 1974 to that in 1979?
Your response must be concise. 0.94. What is the ratio of the General Parity Index (GPI) in Trinidad and Tobago in 1974 to that in 1979?
Provide a short and direct response. 0.99. What is the ratio of the General Parity Index (GPI) of European Union in 1974 to that in 1980?
Keep it short and to the point. 1. What is the ratio of the General Parity Index (GPI) of Cabo Verde in 1974 to that in 1980?
Keep it short and to the point. 1.02. What is the ratio of the General Parity Index (GPI) in Solomon Islands in 1974 to that in 1980?
Provide a short and direct response. 0.9. What is the ratio of the General Parity Index (GPI) of Cabo Verde in 1974 to that in 1981?
Ensure brevity in your answer.  1.02. What is the ratio of the General Parity Index (GPI) of Solomon Islands in 1974 to that in 1981?
Your answer should be compact. 0.9. What is the ratio of the General Parity Index (GPI) of Trinidad and Tobago in 1974 to that in 1981?
Keep it short and to the point. 0.97. What is the ratio of the General Parity Index (GPI) in European Union in 1975 to that in 1977?
Keep it short and to the point. 1. What is the ratio of the General Parity Index (GPI) in Cabo Verde in 1975 to that in 1977?
Keep it short and to the point. 1.01. What is the ratio of the General Parity Index (GPI) in Solomon Islands in 1975 to that in 1977?
Ensure brevity in your answer.  0.9. What is the ratio of the General Parity Index (GPI) of Trinidad and Tobago in 1975 to that in 1977?
Provide a short and direct response. 1. What is the ratio of the General Parity Index (GPI) of Cabo Verde in 1975 to that in 1978?
Make the answer very short. 1. What is the ratio of the General Parity Index (GPI) in Solomon Islands in 1975 to that in 1978?
Your answer should be very brief. 0.93. What is the ratio of the General Parity Index (GPI) in Trinidad and Tobago in 1975 to that in 1978?
Give a very brief answer. 1. What is the ratio of the General Parity Index (GPI) of Cabo Verde in 1975 to that in 1979?
Provide a short and direct response. 1. What is the ratio of the General Parity Index (GPI) in Solomon Islands in 1975 to that in 1979?
Your answer should be compact. 0.9. What is the ratio of the General Parity Index (GPI) in Trinidad and Tobago in 1975 to that in 1979?
Make the answer very short. 0.99. What is the ratio of the General Parity Index (GPI) in Solomon Islands in 1975 to that in 1980?
Offer a very short reply. 0.87. What is the ratio of the General Parity Index (GPI) of Trinidad and Tobago in 1975 to that in 1980?
Offer a very short reply. 1. What is the ratio of the General Parity Index (GPI) in Cabo Verde in 1975 to that in 1981?
Provide a succinct answer. 1.01. What is the ratio of the General Parity Index (GPI) of Solomon Islands in 1975 to that in 1981?
Your response must be concise. 0.87. What is the ratio of the General Parity Index (GPI) of Trinidad and Tobago in 1975 to that in 1981?
Ensure brevity in your answer.  0.97. What is the ratio of the General Parity Index (GPI) of European Union in 1977 to that in 1978?
Offer a terse response. 1. What is the ratio of the General Parity Index (GPI) in Solomon Islands in 1977 to that in 1978?
Give a very brief answer. 1.03. What is the ratio of the General Parity Index (GPI) of Cabo Verde in 1977 to that in 1979?
Your response must be concise. 0.99. What is the ratio of the General Parity Index (GPI) of European Union in 1977 to that in 1980?
Your answer should be very brief. 1. What is the ratio of the General Parity Index (GPI) of Cabo Verde in 1977 to that in 1980?
Offer a very short reply. 1. What is the ratio of the General Parity Index (GPI) in Solomon Islands in 1977 to that in 1980?
Provide a succinct answer. 0.97. What is the ratio of the General Parity Index (GPI) of European Union in 1977 to that in 1981?
Keep it short and to the point. 1. What is the ratio of the General Parity Index (GPI) of Cabo Verde in 1977 to that in 1981?
Give a very brief answer. 1. What is the ratio of the General Parity Index (GPI) of Solomon Islands in 1977 to that in 1981?
Your answer should be compact. 0.96. What is the ratio of the General Parity Index (GPI) in Trinidad and Tobago in 1977 to that in 1981?
Your response must be concise. 0.97. What is the ratio of the General Parity Index (GPI) in European Union in 1978 to that in 1979?
Your answer should be very brief. 1. What is the ratio of the General Parity Index (GPI) in Solomon Islands in 1978 to that in 1979?
Keep it short and to the point. 0.97. What is the ratio of the General Parity Index (GPI) of Trinidad and Tobago in 1978 to that in 1979?
Your answer should be compact. 1. What is the ratio of the General Parity Index (GPI) in Cabo Verde in 1978 to that in 1980?
Offer a terse response. 1. What is the ratio of the General Parity Index (GPI) in Solomon Islands in 1978 to that in 1980?
Keep it short and to the point. 0.93. What is the ratio of the General Parity Index (GPI) in Cabo Verde in 1978 to that in 1981?
Give a very brief answer. 1.01. What is the ratio of the General Parity Index (GPI) in Solomon Islands in 1978 to that in 1981?
Offer a very short reply. 0.93. What is the ratio of the General Parity Index (GPI) in Trinidad and Tobago in 1978 to that in 1981?
Your response must be concise. 0.98. What is the ratio of the General Parity Index (GPI) of European Union in 1979 to that in 1980?
Ensure brevity in your answer.  1. What is the ratio of the General Parity Index (GPI) of Cabo Verde in 1979 to that in 1980?
Your response must be concise. 1.01. What is the ratio of the General Parity Index (GPI) of Solomon Islands in 1979 to that in 1980?
Your answer should be compact. 0.96. What is the ratio of the General Parity Index (GPI) in Trinidad and Tobago in 1979 to that in 1980?
Your answer should be very brief. 1.01. What is the ratio of the General Parity Index (GPI) in Cabo Verde in 1979 to that in 1981?
Make the answer very short. 1.01. What is the ratio of the General Parity Index (GPI) of Solomon Islands in 1979 to that in 1981?
Provide a succinct answer. 0.96. What is the ratio of the General Parity Index (GPI) in Trinidad and Tobago in 1979 to that in 1981?
Provide a short and direct response. 0.98. What is the ratio of the General Parity Index (GPI) of European Union in 1980 to that in 1981?
Make the answer very short. 1. What is the ratio of the General Parity Index (GPI) in Cabo Verde in 1980 to that in 1981?
Your answer should be very brief. 1. What is the ratio of the General Parity Index (GPI) of Trinidad and Tobago in 1980 to that in 1981?
Make the answer very short. 0.97. What is the difference between the highest and the second highest General Parity Index (GPI) of European Union?
Ensure brevity in your answer.  0. What is the difference between the highest and the second highest General Parity Index (GPI) of Cabo Verde?
Provide a succinct answer. 0.01. What is the difference between the highest and the second highest General Parity Index (GPI) in Solomon Islands?
Provide a short and direct response. 0. What is the difference between the highest and the second highest General Parity Index (GPI) in Trinidad and Tobago?
Your answer should be compact. 0.02. What is the difference between the highest and the lowest General Parity Index (GPI) in European Union?
Your answer should be very brief. 0. What is the difference between the highest and the lowest General Parity Index (GPI) in Cabo Verde?
Your answer should be very brief. 0.02. What is the difference between the highest and the lowest General Parity Index (GPI) of Solomon Islands?
Ensure brevity in your answer.  0.1. What is the difference between the highest and the lowest General Parity Index (GPI) of Trinidad and Tobago?
Your response must be concise. 0.03. 